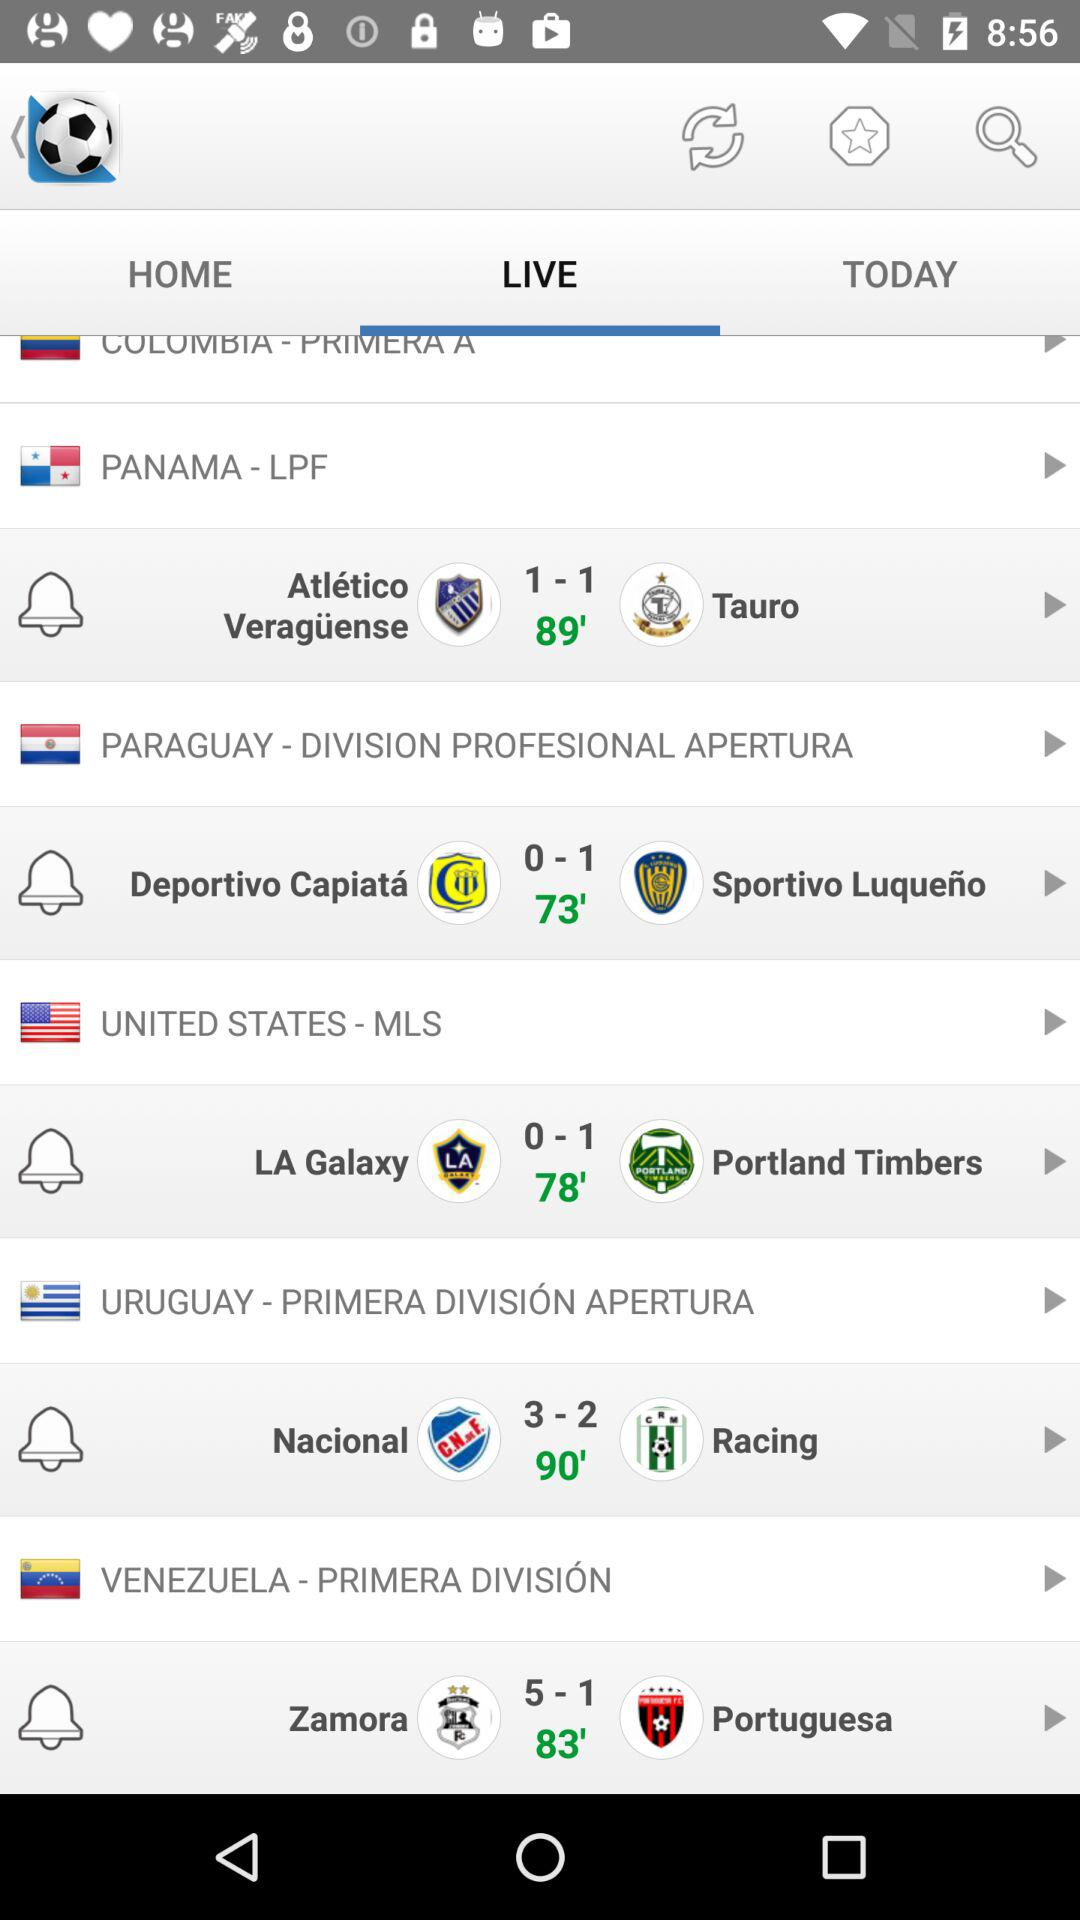What's the score of "Nacional" and "Racing"? The scores of "Nacional" and "Racing" are 3 and 2, respectively. 